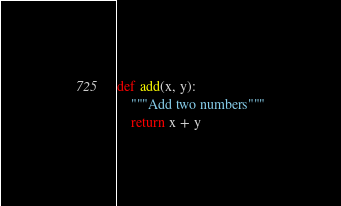Convert code to text. <code><loc_0><loc_0><loc_500><loc_500><_Python_>def add(x, y):
	"""Add two numbers"""
	return x + y
</code> 